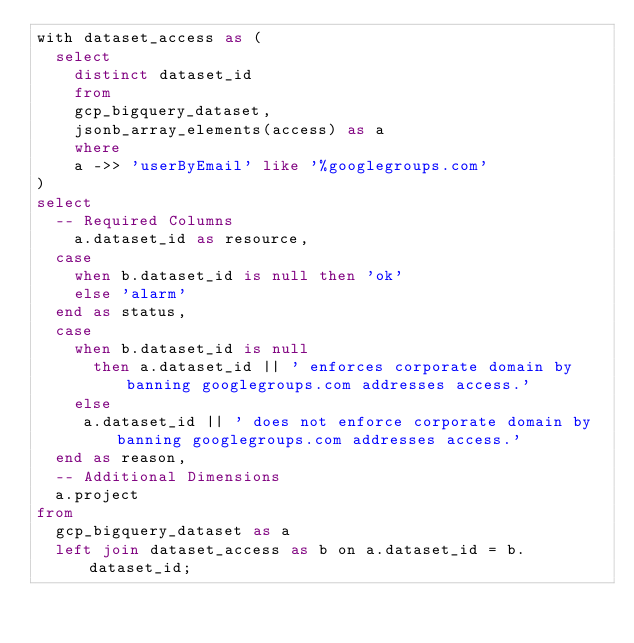<code> <loc_0><loc_0><loc_500><loc_500><_SQL_>with dataset_access as (
  select 
    distinct dataset_id
    from 
    gcp_bigquery_dataset,
    jsonb_array_elements(access) as a
    where
    a ->> 'userByEmail' like '%googlegroups.com'
)
select
  -- Required Columns
    a.dataset_id as resource,
  case
    when b.dataset_id is null then 'ok'
    else 'alarm'
  end as status,
  case
    when b.dataset_id is null
      then a.dataset_id || ' enforces corporate domain by banning googlegroups.com addresses access.'
    else 
     a.dataset_id || ' does not enforce corporate domain by banning googlegroups.com addresses access.'
  end as reason,
  -- Additional Dimensions
  a.project
from
  gcp_bigquery_dataset as a
  left join dataset_access as b on a.dataset_id = b.dataset_id;</code> 